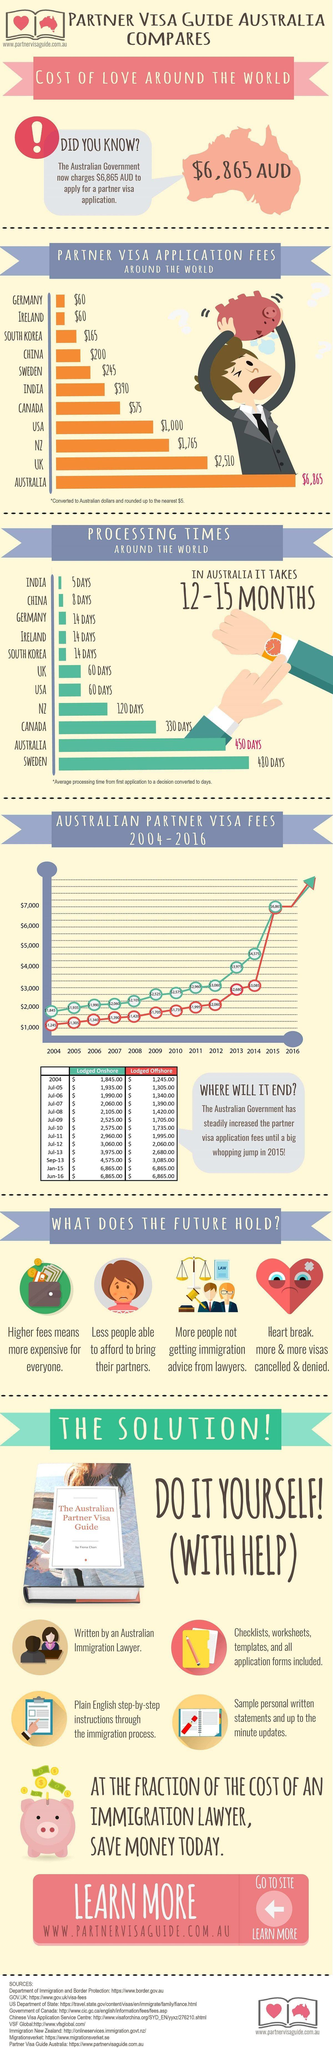Indicate a few pertinent items in this graphic. Australia has the second longest processing time among countries. The increase in visa application fees for offshore applications from 2004 to June 2016 was $5,620.00. India is the country with the least amount of processing time. As of June 2016, the increase in visa application fees for onshore lodgement from 2004 was $5,020.00. The country with the fourth highest fees for partner visa application is the United States of America. 